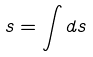<formula> <loc_0><loc_0><loc_500><loc_500>s = \int d s</formula> 